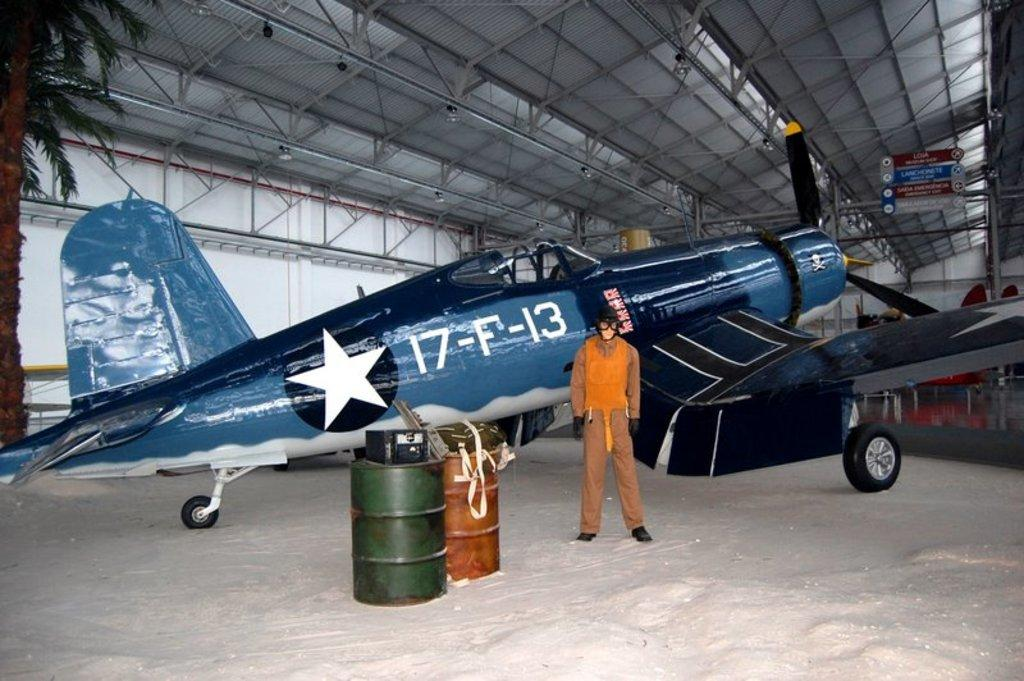What is the main subject in the center of the image? There is an aircraft in the center of the image. What other objects can be seen in the image? There are barrels, a tree, sign boards, and other objects in the image. Can you describe the person standing in the image? There is a person standing in the image, but no specific details about their appearance or actions are provided. What might the sign boards be used for in the image? The sign boards in the image could be used for providing information or directions. Where is the calculator located in the image? There is no calculator present in the image. Can you describe the contents of the drawer in the image? There is no drawer present in the image. 